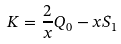Convert formula to latex. <formula><loc_0><loc_0><loc_500><loc_500>K = \frac { 2 } { x } Q _ { 0 } - x S _ { 1 }</formula> 